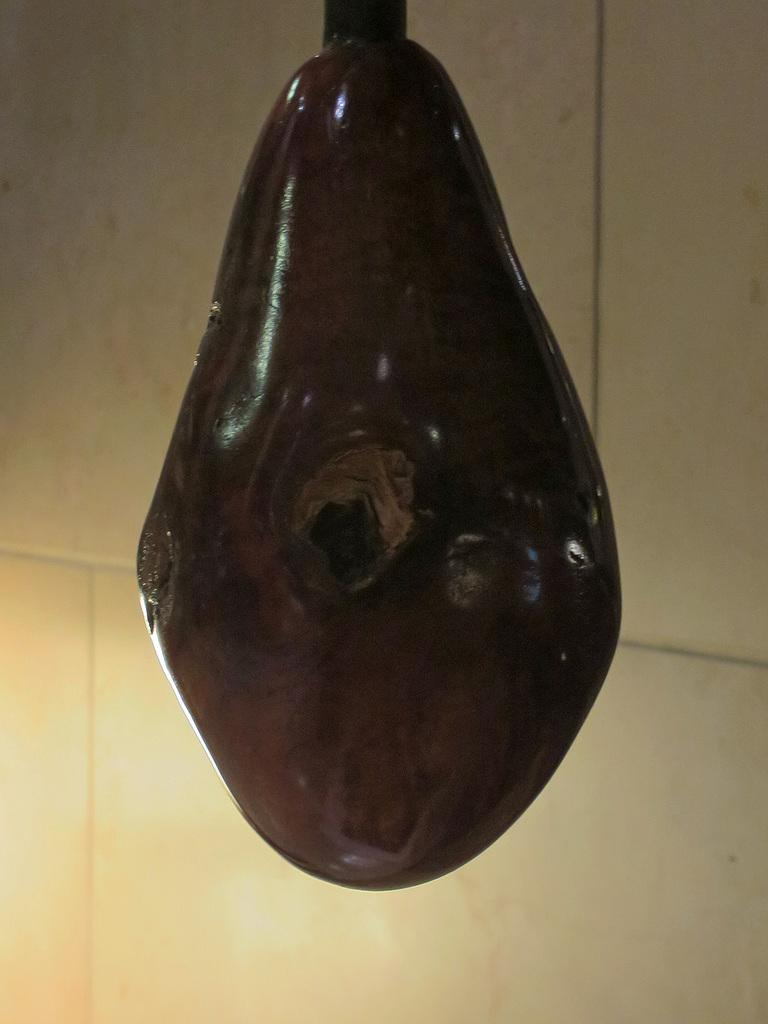What type of material is featured in the image? There is a ceramic material in the image. What color is the ceramic material? The ceramic material is brown in color. What can be seen in the background of the image? There is a wall in the background of the image. What color is the wall? The wall is white in color. How many people are sleeping in the crowd in the image? There is no crowd or people sleeping in the image; it features a brown ceramic material and a white wall in the background. 